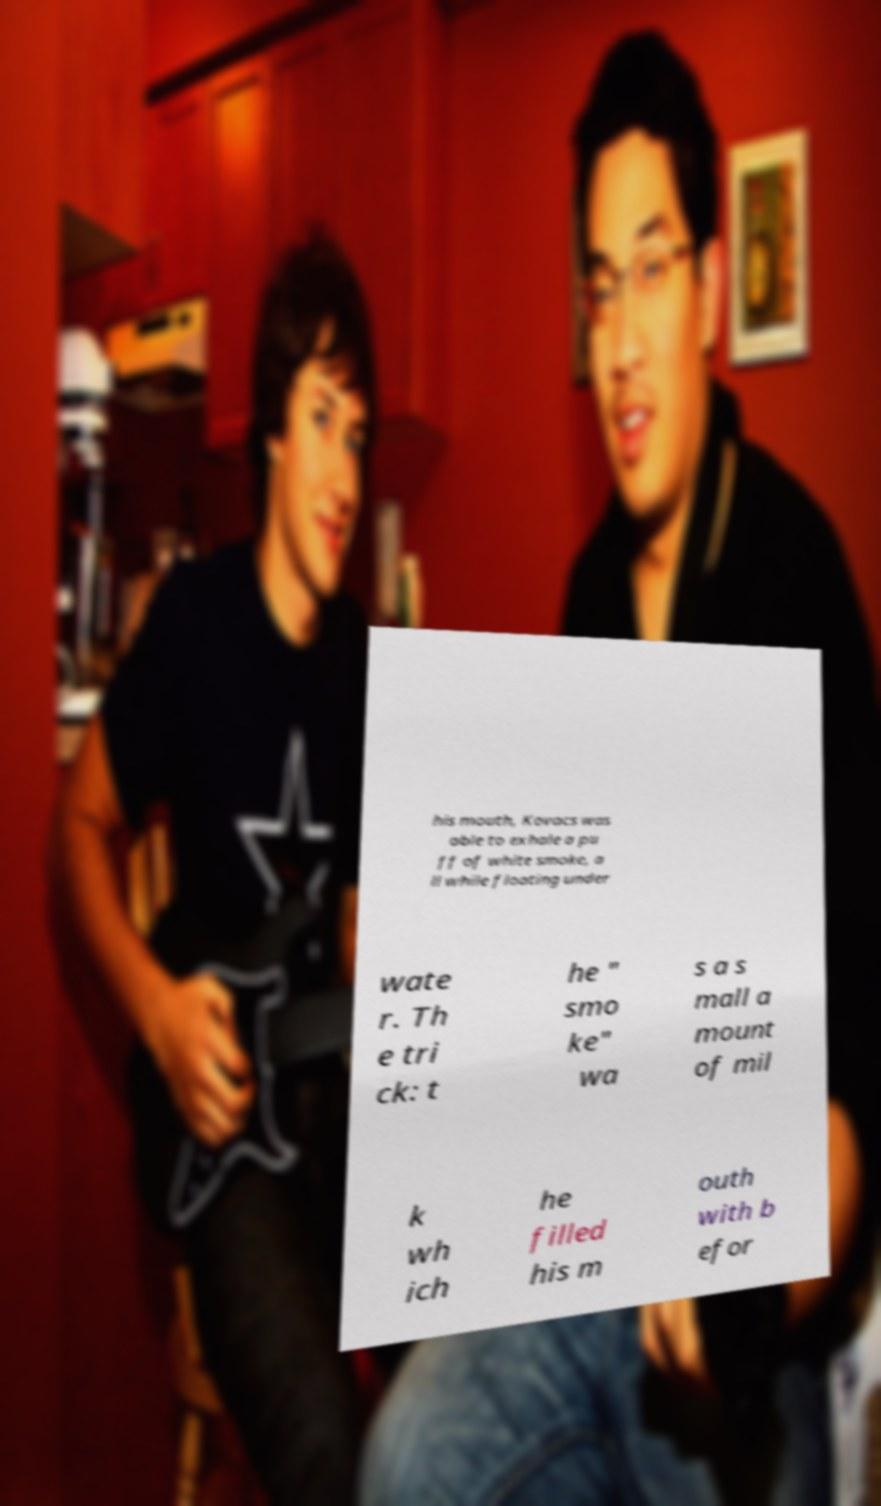I need the written content from this picture converted into text. Can you do that? his mouth, Kovacs was able to exhale a pu ff of white smoke, a ll while floating under wate r. Th e tri ck: t he " smo ke" wa s a s mall a mount of mil k wh ich he filled his m outh with b efor 